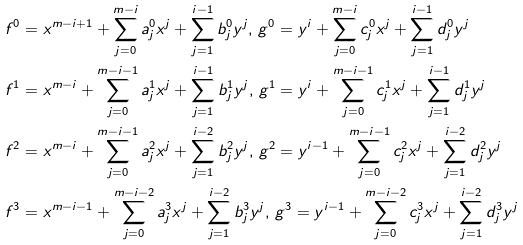Convert formula to latex. <formula><loc_0><loc_0><loc_500><loc_500>& f ^ { 0 } = x ^ { m - i + 1 } + \sum ^ { m - i } _ { j = 0 } a _ { j } ^ { 0 } x ^ { j } + \sum ^ { i - 1 } _ { j = 1 } b _ { j } ^ { 0 } y ^ { j } , \, g ^ { 0 } = y ^ { i } + \sum ^ { m - i } _ { j = 0 } c _ { j } ^ { 0 } x ^ { j } + \sum ^ { i - 1 } _ { j = 1 } d _ { j } ^ { 0 } y ^ { j } \\ & f ^ { 1 } = x ^ { m - i } + \sum ^ { m - i - 1 } _ { j = 0 } a _ { j } ^ { 1 } x ^ { j } + \sum ^ { i - 1 } _ { j = 1 } b _ { j } ^ { 1 } y ^ { j } , \, g ^ { 1 } = y ^ { i } + \sum ^ { m - i - 1 } _ { j = 0 } c _ { j } ^ { 1 } x ^ { j } + \sum ^ { i - 1 } _ { j = 1 } d _ { j } ^ { 1 } y ^ { j } \\ & f ^ { 2 } = x ^ { m - i } + \sum ^ { m - i - 1 } _ { j = 0 } a _ { j } ^ { 2 } x ^ { j } + \sum ^ { i - 2 } _ { j = 1 } b _ { j } ^ { 2 } y ^ { j } , \, g ^ { 2 } = y ^ { i - 1 } + \sum ^ { m - i - 1 } _ { j = 0 } c _ { j } ^ { 2 } x ^ { j } + \sum ^ { i - 2 } _ { j = 1 } d _ { j } ^ { 2 } y ^ { j } \\ & f ^ { 3 } = x ^ { m - i - 1 } + \sum ^ { m - i - 2 } _ { j = 0 } a _ { j } ^ { 3 } x ^ { j } + \sum ^ { i - 2 } _ { j = 1 } b _ { j } ^ { 3 } y ^ { j } , \, g ^ { 3 } = y ^ { i - 1 } + \sum ^ { m - i - 2 } _ { j = 0 } c _ { j } ^ { 3 } x ^ { j } + \sum ^ { i - 2 } _ { j = 1 } d _ { j } ^ { 3 } y ^ { j }</formula> 